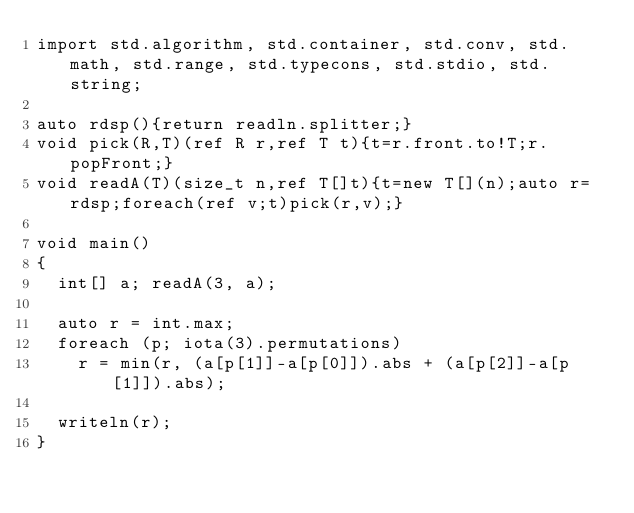Convert code to text. <code><loc_0><loc_0><loc_500><loc_500><_D_>import std.algorithm, std.container, std.conv, std.math, std.range, std.typecons, std.stdio, std.string;

auto rdsp(){return readln.splitter;}
void pick(R,T)(ref R r,ref T t){t=r.front.to!T;r.popFront;}
void readA(T)(size_t n,ref T[]t){t=new T[](n);auto r=rdsp;foreach(ref v;t)pick(r,v);}

void main()
{
  int[] a; readA(3, a);

  auto r = int.max;
  foreach (p; iota(3).permutations)
    r = min(r, (a[p[1]]-a[p[0]]).abs + (a[p[2]]-a[p[1]]).abs);

  writeln(r);
}
</code> 